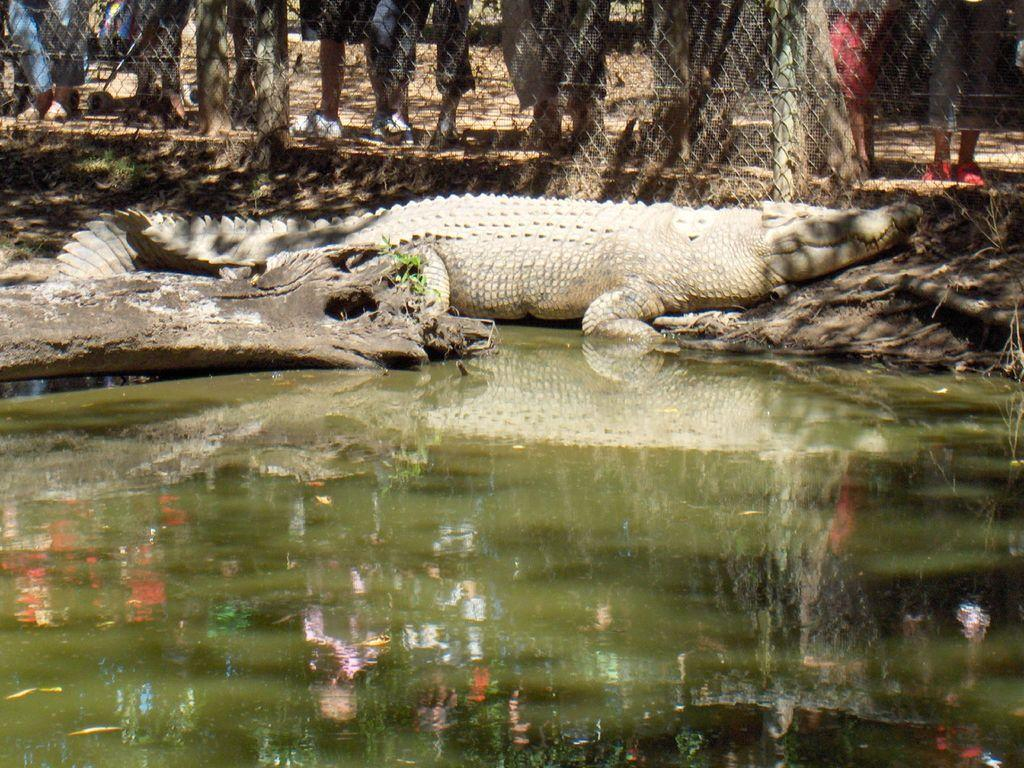What animal can be seen on the ground in the image? There is a crocodile on the ground in the image. What natural element is visible in the image? There is water visible in the image. What type of vegetation is present in the image? There are plants in the image. What type of structure can be seen in the image? There are wooden poles in the image. What are the people in the image doing? There is a group of people standing beside a metal fence in the image. What type of linen is draped over the crocodile in the image? There is no linen present in the image, and the crocodile is not draped with any fabric. 